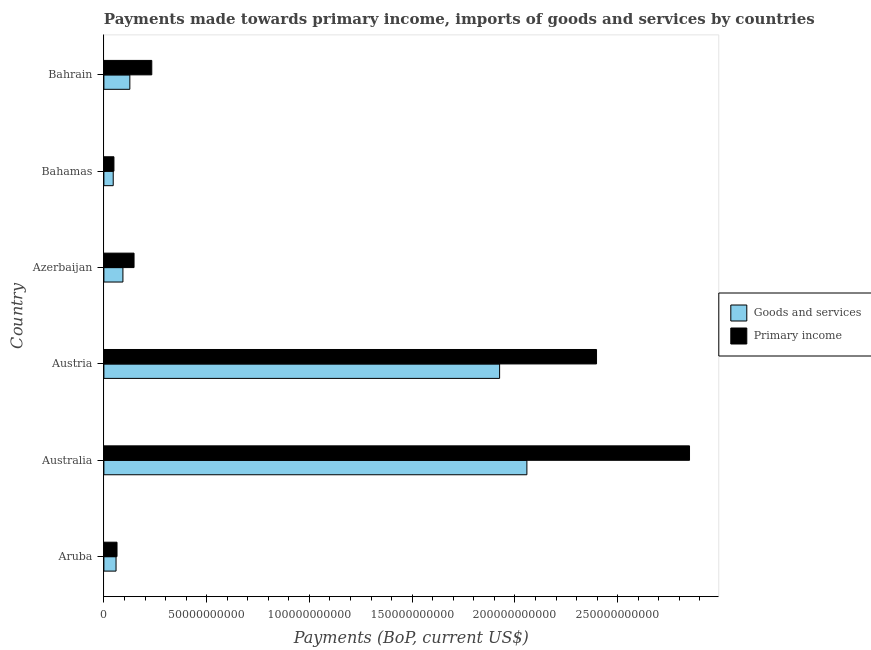How many groups of bars are there?
Offer a very short reply. 6. Are the number of bars per tick equal to the number of legend labels?
Provide a short and direct response. Yes. How many bars are there on the 4th tick from the bottom?
Offer a very short reply. 2. What is the label of the 1st group of bars from the top?
Your answer should be compact. Bahrain. What is the payments made towards primary income in Azerbaijan?
Ensure brevity in your answer.  1.47e+1. Across all countries, what is the maximum payments made towards primary income?
Give a very brief answer. 2.85e+11. Across all countries, what is the minimum payments made towards primary income?
Your response must be concise. 4.89e+09. In which country was the payments made towards primary income minimum?
Give a very brief answer. Bahamas. What is the total payments made towards goods and services in the graph?
Keep it short and to the point. 4.31e+11. What is the difference between the payments made towards goods and services in Australia and that in Azerbaijan?
Give a very brief answer. 1.97e+11. What is the difference between the payments made towards goods and services in Azerbaijan and the payments made towards primary income in Bahrain?
Provide a short and direct response. -1.40e+1. What is the average payments made towards primary income per country?
Offer a terse response. 9.57e+1. What is the difference between the payments made towards goods and services and payments made towards primary income in Austria?
Ensure brevity in your answer.  -4.72e+1. In how many countries, is the payments made towards primary income greater than 280000000000 US$?
Ensure brevity in your answer.  1. What is the ratio of the payments made towards primary income in Aruba to that in Bahrain?
Keep it short and to the point. 0.27. Is the payments made towards primary income in Aruba less than that in Bahrain?
Provide a short and direct response. Yes. What is the difference between the highest and the second highest payments made towards primary income?
Your response must be concise. 4.52e+1. What is the difference between the highest and the lowest payments made towards primary income?
Your answer should be very brief. 2.80e+11. Is the sum of the payments made towards primary income in Bahamas and Bahrain greater than the maximum payments made towards goods and services across all countries?
Offer a terse response. No. What does the 1st bar from the top in Austria represents?
Ensure brevity in your answer.  Primary income. What does the 2nd bar from the bottom in Bahrain represents?
Provide a succinct answer. Primary income. Are the values on the major ticks of X-axis written in scientific E-notation?
Provide a short and direct response. No. Does the graph contain any zero values?
Your response must be concise. No. What is the title of the graph?
Keep it short and to the point. Payments made towards primary income, imports of goods and services by countries. Does "Commercial service exports" appear as one of the legend labels in the graph?
Offer a terse response. No. What is the label or title of the X-axis?
Your response must be concise. Payments (BoP, current US$). What is the Payments (BoP, current US$) of Goods and services in Aruba?
Make the answer very short. 5.91e+09. What is the Payments (BoP, current US$) in Primary income in Aruba?
Provide a short and direct response. 6.39e+09. What is the Payments (BoP, current US$) of Goods and services in Australia?
Ensure brevity in your answer.  2.06e+11. What is the Payments (BoP, current US$) in Primary income in Australia?
Offer a very short reply. 2.85e+11. What is the Payments (BoP, current US$) in Goods and services in Austria?
Keep it short and to the point. 1.93e+11. What is the Payments (BoP, current US$) of Primary income in Austria?
Give a very brief answer. 2.40e+11. What is the Payments (BoP, current US$) of Goods and services in Azerbaijan?
Your response must be concise. 9.26e+09. What is the Payments (BoP, current US$) of Primary income in Azerbaijan?
Your answer should be compact. 1.47e+1. What is the Payments (BoP, current US$) in Goods and services in Bahamas?
Give a very brief answer. 4.54e+09. What is the Payments (BoP, current US$) in Primary income in Bahamas?
Your answer should be very brief. 4.89e+09. What is the Payments (BoP, current US$) of Goods and services in Bahrain?
Your answer should be compact. 1.26e+1. What is the Payments (BoP, current US$) in Primary income in Bahrain?
Your answer should be very brief. 2.33e+1. Across all countries, what is the maximum Payments (BoP, current US$) of Goods and services?
Offer a very short reply. 2.06e+11. Across all countries, what is the maximum Payments (BoP, current US$) of Primary income?
Offer a terse response. 2.85e+11. Across all countries, what is the minimum Payments (BoP, current US$) of Goods and services?
Ensure brevity in your answer.  4.54e+09. Across all countries, what is the minimum Payments (BoP, current US$) in Primary income?
Your answer should be very brief. 4.89e+09. What is the total Payments (BoP, current US$) in Goods and services in the graph?
Give a very brief answer. 4.31e+11. What is the total Payments (BoP, current US$) in Primary income in the graph?
Make the answer very short. 5.74e+11. What is the difference between the Payments (BoP, current US$) of Goods and services in Aruba and that in Australia?
Provide a short and direct response. -2.00e+11. What is the difference between the Payments (BoP, current US$) in Primary income in Aruba and that in Australia?
Ensure brevity in your answer.  -2.79e+11. What is the difference between the Payments (BoP, current US$) in Goods and services in Aruba and that in Austria?
Keep it short and to the point. -1.87e+11. What is the difference between the Payments (BoP, current US$) of Primary income in Aruba and that in Austria?
Offer a terse response. -2.33e+11. What is the difference between the Payments (BoP, current US$) in Goods and services in Aruba and that in Azerbaijan?
Ensure brevity in your answer.  -3.35e+09. What is the difference between the Payments (BoP, current US$) of Primary income in Aruba and that in Azerbaijan?
Your response must be concise. -8.28e+09. What is the difference between the Payments (BoP, current US$) in Goods and services in Aruba and that in Bahamas?
Offer a terse response. 1.37e+09. What is the difference between the Payments (BoP, current US$) of Primary income in Aruba and that in Bahamas?
Give a very brief answer. 1.50e+09. What is the difference between the Payments (BoP, current US$) of Goods and services in Aruba and that in Bahrain?
Make the answer very short. -6.71e+09. What is the difference between the Payments (BoP, current US$) of Primary income in Aruba and that in Bahrain?
Give a very brief answer. -1.69e+1. What is the difference between the Payments (BoP, current US$) of Goods and services in Australia and that in Austria?
Offer a terse response. 1.33e+1. What is the difference between the Payments (BoP, current US$) in Primary income in Australia and that in Austria?
Offer a very short reply. 4.52e+1. What is the difference between the Payments (BoP, current US$) of Goods and services in Australia and that in Azerbaijan?
Your response must be concise. 1.97e+11. What is the difference between the Payments (BoP, current US$) in Primary income in Australia and that in Azerbaijan?
Your answer should be compact. 2.70e+11. What is the difference between the Payments (BoP, current US$) of Goods and services in Australia and that in Bahamas?
Provide a short and direct response. 2.01e+11. What is the difference between the Payments (BoP, current US$) in Primary income in Australia and that in Bahamas?
Your answer should be very brief. 2.80e+11. What is the difference between the Payments (BoP, current US$) of Goods and services in Australia and that in Bahrain?
Provide a succinct answer. 1.93e+11. What is the difference between the Payments (BoP, current US$) in Primary income in Australia and that in Bahrain?
Your response must be concise. 2.62e+11. What is the difference between the Payments (BoP, current US$) of Goods and services in Austria and that in Azerbaijan?
Keep it short and to the point. 1.83e+11. What is the difference between the Payments (BoP, current US$) of Primary income in Austria and that in Azerbaijan?
Offer a very short reply. 2.25e+11. What is the difference between the Payments (BoP, current US$) of Goods and services in Austria and that in Bahamas?
Your response must be concise. 1.88e+11. What is the difference between the Payments (BoP, current US$) in Primary income in Austria and that in Bahamas?
Offer a very short reply. 2.35e+11. What is the difference between the Payments (BoP, current US$) of Goods and services in Austria and that in Bahrain?
Your answer should be very brief. 1.80e+11. What is the difference between the Payments (BoP, current US$) in Primary income in Austria and that in Bahrain?
Your answer should be compact. 2.16e+11. What is the difference between the Payments (BoP, current US$) in Goods and services in Azerbaijan and that in Bahamas?
Your answer should be very brief. 4.73e+09. What is the difference between the Payments (BoP, current US$) in Primary income in Azerbaijan and that in Bahamas?
Make the answer very short. 9.78e+09. What is the difference between the Payments (BoP, current US$) of Goods and services in Azerbaijan and that in Bahrain?
Your answer should be compact. -3.36e+09. What is the difference between the Payments (BoP, current US$) in Primary income in Azerbaijan and that in Bahrain?
Your answer should be very brief. -8.63e+09. What is the difference between the Payments (BoP, current US$) in Goods and services in Bahamas and that in Bahrain?
Give a very brief answer. -8.09e+09. What is the difference between the Payments (BoP, current US$) in Primary income in Bahamas and that in Bahrain?
Your answer should be compact. -1.84e+1. What is the difference between the Payments (BoP, current US$) of Goods and services in Aruba and the Payments (BoP, current US$) of Primary income in Australia?
Make the answer very short. -2.79e+11. What is the difference between the Payments (BoP, current US$) of Goods and services in Aruba and the Payments (BoP, current US$) of Primary income in Austria?
Your answer should be compact. -2.34e+11. What is the difference between the Payments (BoP, current US$) in Goods and services in Aruba and the Payments (BoP, current US$) in Primary income in Azerbaijan?
Make the answer very short. -8.76e+09. What is the difference between the Payments (BoP, current US$) in Goods and services in Aruba and the Payments (BoP, current US$) in Primary income in Bahamas?
Give a very brief answer. 1.02e+09. What is the difference between the Payments (BoP, current US$) in Goods and services in Aruba and the Payments (BoP, current US$) in Primary income in Bahrain?
Provide a short and direct response. -1.74e+1. What is the difference between the Payments (BoP, current US$) of Goods and services in Australia and the Payments (BoP, current US$) of Primary income in Austria?
Offer a terse response. -3.39e+1. What is the difference between the Payments (BoP, current US$) of Goods and services in Australia and the Payments (BoP, current US$) of Primary income in Azerbaijan?
Provide a short and direct response. 1.91e+11. What is the difference between the Payments (BoP, current US$) of Goods and services in Australia and the Payments (BoP, current US$) of Primary income in Bahamas?
Your answer should be compact. 2.01e+11. What is the difference between the Payments (BoP, current US$) of Goods and services in Australia and the Payments (BoP, current US$) of Primary income in Bahrain?
Offer a terse response. 1.83e+11. What is the difference between the Payments (BoP, current US$) in Goods and services in Austria and the Payments (BoP, current US$) in Primary income in Azerbaijan?
Ensure brevity in your answer.  1.78e+11. What is the difference between the Payments (BoP, current US$) of Goods and services in Austria and the Payments (BoP, current US$) of Primary income in Bahamas?
Your response must be concise. 1.88e+11. What is the difference between the Payments (BoP, current US$) in Goods and services in Austria and the Payments (BoP, current US$) in Primary income in Bahrain?
Make the answer very short. 1.69e+11. What is the difference between the Payments (BoP, current US$) of Goods and services in Azerbaijan and the Payments (BoP, current US$) of Primary income in Bahamas?
Provide a succinct answer. 4.37e+09. What is the difference between the Payments (BoP, current US$) of Goods and services in Azerbaijan and the Payments (BoP, current US$) of Primary income in Bahrain?
Make the answer very short. -1.40e+1. What is the difference between the Payments (BoP, current US$) in Goods and services in Bahamas and the Payments (BoP, current US$) in Primary income in Bahrain?
Your response must be concise. -1.88e+1. What is the average Payments (BoP, current US$) in Goods and services per country?
Provide a short and direct response. 7.18e+1. What is the average Payments (BoP, current US$) of Primary income per country?
Give a very brief answer. 9.57e+1. What is the difference between the Payments (BoP, current US$) in Goods and services and Payments (BoP, current US$) in Primary income in Aruba?
Offer a terse response. -4.75e+08. What is the difference between the Payments (BoP, current US$) in Goods and services and Payments (BoP, current US$) in Primary income in Australia?
Ensure brevity in your answer.  -7.91e+1. What is the difference between the Payments (BoP, current US$) of Goods and services and Payments (BoP, current US$) of Primary income in Austria?
Offer a very short reply. -4.72e+1. What is the difference between the Payments (BoP, current US$) in Goods and services and Payments (BoP, current US$) in Primary income in Azerbaijan?
Provide a short and direct response. -5.41e+09. What is the difference between the Payments (BoP, current US$) of Goods and services and Payments (BoP, current US$) of Primary income in Bahamas?
Your response must be concise. -3.53e+08. What is the difference between the Payments (BoP, current US$) of Goods and services and Payments (BoP, current US$) of Primary income in Bahrain?
Keep it short and to the point. -1.07e+1. What is the ratio of the Payments (BoP, current US$) of Goods and services in Aruba to that in Australia?
Offer a terse response. 0.03. What is the ratio of the Payments (BoP, current US$) of Primary income in Aruba to that in Australia?
Your response must be concise. 0.02. What is the ratio of the Payments (BoP, current US$) of Goods and services in Aruba to that in Austria?
Ensure brevity in your answer.  0.03. What is the ratio of the Payments (BoP, current US$) in Primary income in Aruba to that in Austria?
Offer a terse response. 0.03. What is the ratio of the Payments (BoP, current US$) in Goods and services in Aruba to that in Azerbaijan?
Give a very brief answer. 0.64. What is the ratio of the Payments (BoP, current US$) of Primary income in Aruba to that in Azerbaijan?
Your response must be concise. 0.44. What is the ratio of the Payments (BoP, current US$) in Goods and services in Aruba to that in Bahamas?
Your answer should be compact. 1.3. What is the ratio of the Payments (BoP, current US$) of Primary income in Aruba to that in Bahamas?
Your answer should be compact. 1.31. What is the ratio of the Payments (BoP, current US$) of Goods and services in Aruba to that in Bahrain?
Your answer should be very brief. 0.47. What is the ratio of the Payments (BoP, current US$) of Primary income in Aruba to that in Bahrain?
Ensure brevity in your answer.  0.27. What is the ratio of the Payments (BoP, current US$) of Goods and services in Australia to that in Austria?
Your answer should be very brief. 1.07. What is the ratio of the Payments (BoP, current US$) in Primary income in Australia to that in Austria?
Your response must be concise. 1.19. What is the ratio of the Payments (BoP, current US$) in Goods and services in Australia to that in Azerbaijan?
Give a very brief answer. 22.22. What is the ratio of the Payments (BoP, current US$) in Primary income in Australia to that in Azerbaijan?
Ensure brevity in your answer.  19.43. What is the ratio of the Payments (BoP, current US$) of Goods and services in Australia to that in Bahamas?
Provide a succinct answer. 45.37. What is the ratio of the Payments (BoP, current US$) in Primary income in Australia to that in Bahamas?
Ensure brevity in your answer.  58.28. What is the ratio of the Payments (BoP, current US$) in Goods and services in Australia to that in Bahrain?
Your answer should be compact. 16.3. What is the ratio of the Payments (BoP, current US$) in Primary income in Australia to that in Bahrain?
Your response must be concise. 12.23. What is the ratio of the Payments (BoP, current US$) in Goods and services in Austria to that in Azerbaijan?
Make the answer very short. 20.79. What is the ratio of the Payments (BoP, current US$) of Primary income in Austria to that in Azerbaijan?
Ensure brevity in your answer.  16.34. What is the ratio of the Payments (BoP, current US$) in Goods and services in Austria to that in Bahamas?
Ensure brevity in your answer.  42.45. What is the ratio of the Payments (BoP, current US$) in Primary income in Austria to that in Bahamas?
Provide a short and direct response. 49.03. What is the ratio of the Payments (BoP, current US$) in Goods and services in Austria to that in Bahrain?
Your answer should be very brief. 15.25. What is the ratio of the Payments (BoP, current US$) of Primary income in Austria to that in Bahrain?
Your answer should be compact. 10.29. What is the ratio of the Payments (BoP, current US$) of Goods and services in Azerbaijan to that in Bahamas?
Your answer should be compact. 2.04. What is the ratio of the Payments (BoP, current US$) in Primary income in Azerbaijan to that in Bahamas?
Provide a short and direct response. 3. What is the ratio of the Payments (BoP, current US$) of Goods and services in Azerbaijan to that in Bahrain?
Your response must be concise. 0.73. What is the ratio of the Payments (BoP, current US$) of Primary income in Azerbaijan to that in Bahrain?
Your answer should be compact. 0.63. What is the ratio of the Payments (BoP, current US$) of Goods and services in Bahamas to that in Bahrain?
Ensure brevity in your answer.  0.36. What is the ratio of the Payments (BoP, current US$) in Primary income in Bahamas to that in Bahrain?
Ensure brevity in your answer.  0.21. What is the difference between the highest and the second highest Payments (BoP, current US$) in Goods and services?
Provide a succinct answer. 1.33e+1. What is the difference between the highest and the second highest Payments (BoP, current US$) of Primary income?
Your answer should be very brief. 4.52e+1. What is the difference between the highest and the lowest Payments (BoP, current US$) of Goods and services?
Make the answer very short. 2.01e+11. What is the difference between the highest and the lowest Payments (BoP, current US$) of Primary income?
Give a very brief answer. 2.80e+11. 